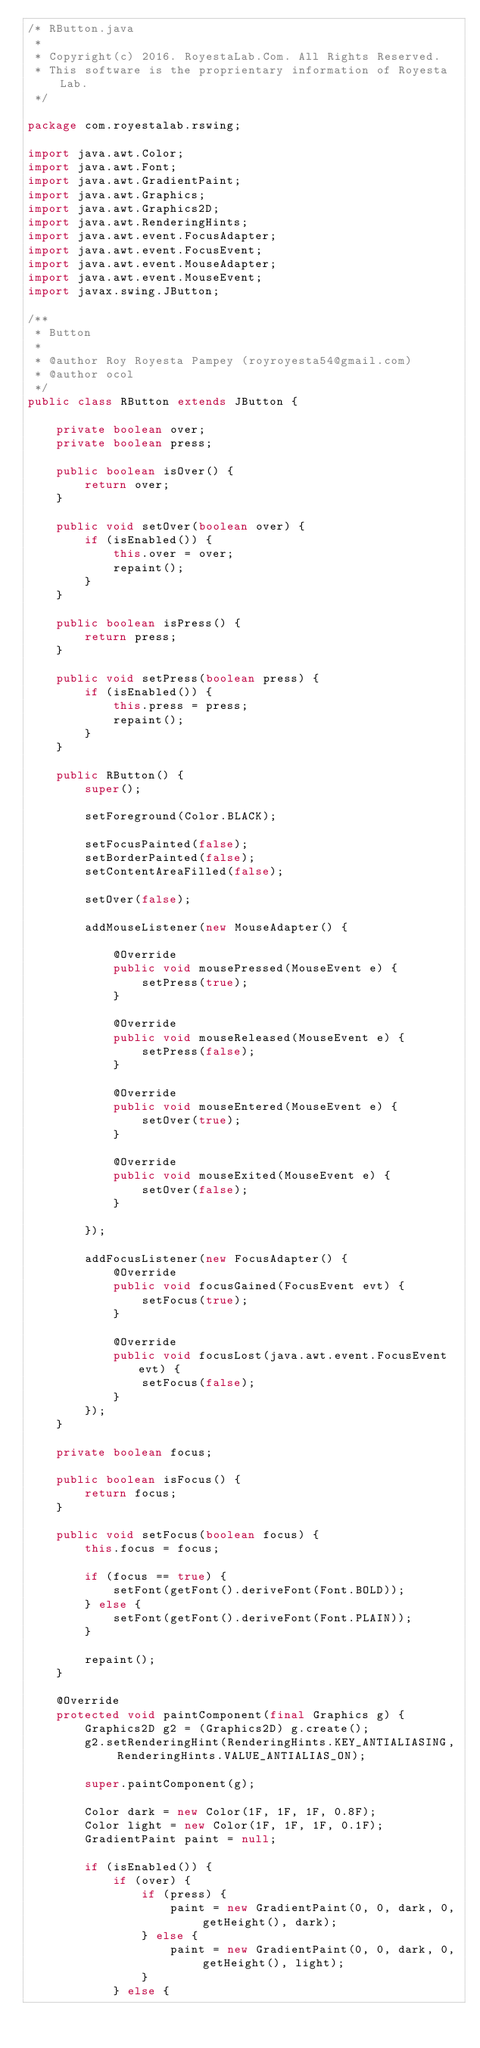Convert code to text. <code><loc_0><loc_0><loc_500><loc_500><_Java_>/* RButton.java
 * 
 * Copyright(c) 2016. RoyestaLab.Com. All Rights Reserved.
 * This software is the proprientary information of Royesta Lab.
 */

package com.royestalab.rswing;

import java.awt.Color;
import java.awt.Font;
import java.awt.GradientPaint;
import java.awt.Graphics;
import java.awt.Graphics2D;
import java.awt.RenderingHints;
import java.awt.event.FocusAdapter;
import java.awt.event.FocusEvent;
import java.awt.event.MouseAdapter;
import java.awt.event.MouseEvent;
import javax.swing.JButton;

/**
 * Button
 * 
 * @author Roy Royesta Pampey (royroyesta54@gmail.com)
 * @author ocol
 */
public class RButton extends JButton {

    private boolean over;
    private boolean press;

    public boolean isOver() {
        return over;
    }

    public void setOver(boolean over) {
        if (isEnabled()) {
            this.over = over;
            repaint();
        }
    }

    public boolean isPress() {
        return press;
    }

    public void setPress(boolean press) {
        if (isEnabled()) {
            this.press = press;
            repaint();
        }
    }

    public RButton() {
        super();

        setForeground(Color.BLACK);

        setFocusPainted(false);
        setBorderPainted(false);
        setContentAreaFilled(false);

        setOver(false);

        addMouseListener(new MouseAdapter() {

            @Override
            public void mousePressed(MouseEvent e) {
                setPress(true);
            }

            @Override
            public void mouseReleased(MouseEvent e) {
                setPress(false);
            }

            @Override
            public void mouseEntered(MouseEvent e) {
                setOver(true);
            }

            @Override
            public void mouseExited(MouseEvent e) {
                setOver(false);
            }

        });

        addFocusListener(new FocusAdapter() {
            @Override
            public void focusGained(FocusEvent evt) {
                setFocus(true);
            }

            @Override
            public void focusLost(java.awt.event.FocusEvent evt) {
                setFocus(false);
            }
        });
    }

    private boolean focus;

    public boolean isFocus() {
        return focus;
    }

    public void setFocus(boolean focus) {
        this.focus = focus;

        if (focus == true) {
            setFont(getFont().deriveFont(Font.BOLD));
        } else {
            setFont(getFont().deriveFont(Font.PLAIN));
        }

        repaint();
    }

    @Override
    protected void paintComponent(final Graphics g) {
        Graphics2D g2 = (Graphics2D) g.create();
        g2.setRenderingHint(RenderingHints.KEY_ANTIALIASING, RenderingHints.VALUE_ANTIALIAS_ON);

        super.paintComponent(g);

        Color dark = new Color(1F, 1F, 1F, 0.8F);
        Color light = new Color(1F, 1F, 1F, 0.1F);
        GradientPaint paint = null;

        if (isEnabled()) {
            if (over) {
                if (press) {
                    paint = new GradientPaint(0, 0, dark, 0, getHeight(), dark);
                } else {
                    paint = new GradientPaint(0, 0, dark, 0, getHeight(), light);
                }
            } else {</code> 